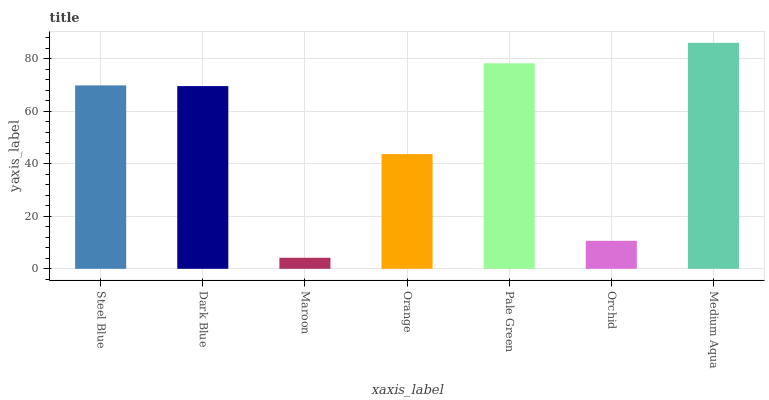Is Maroon the minimum?
Answer yes or no. Yes. Is Medium Aqua the maximum?
Answer yes or no. Yes. Is Dark Blue the minimum?
Answer yes or no. No. Is Dark Blue the maximum?
Answer yes or no. No. Is Steel Blue greater than Dark Blue?
Answer yes or no. Yes. Is Dark Blue less than Steel Blue?
Answer yes or no. Yes. Is Dark Blue greater than Steel Blue?
Answer yes or no. No. Is Steel Blue less than Dark Blue?
Answer yes or no. No. Is Dark Blue the high median?
Answer yes or no. Yes. Is Dark Blue the low median?
Answer yes or no. Yes. Is Steel Blue the high median?
Answer yes or no. No. Is Orange the low median?
Answer yes or no. No. 